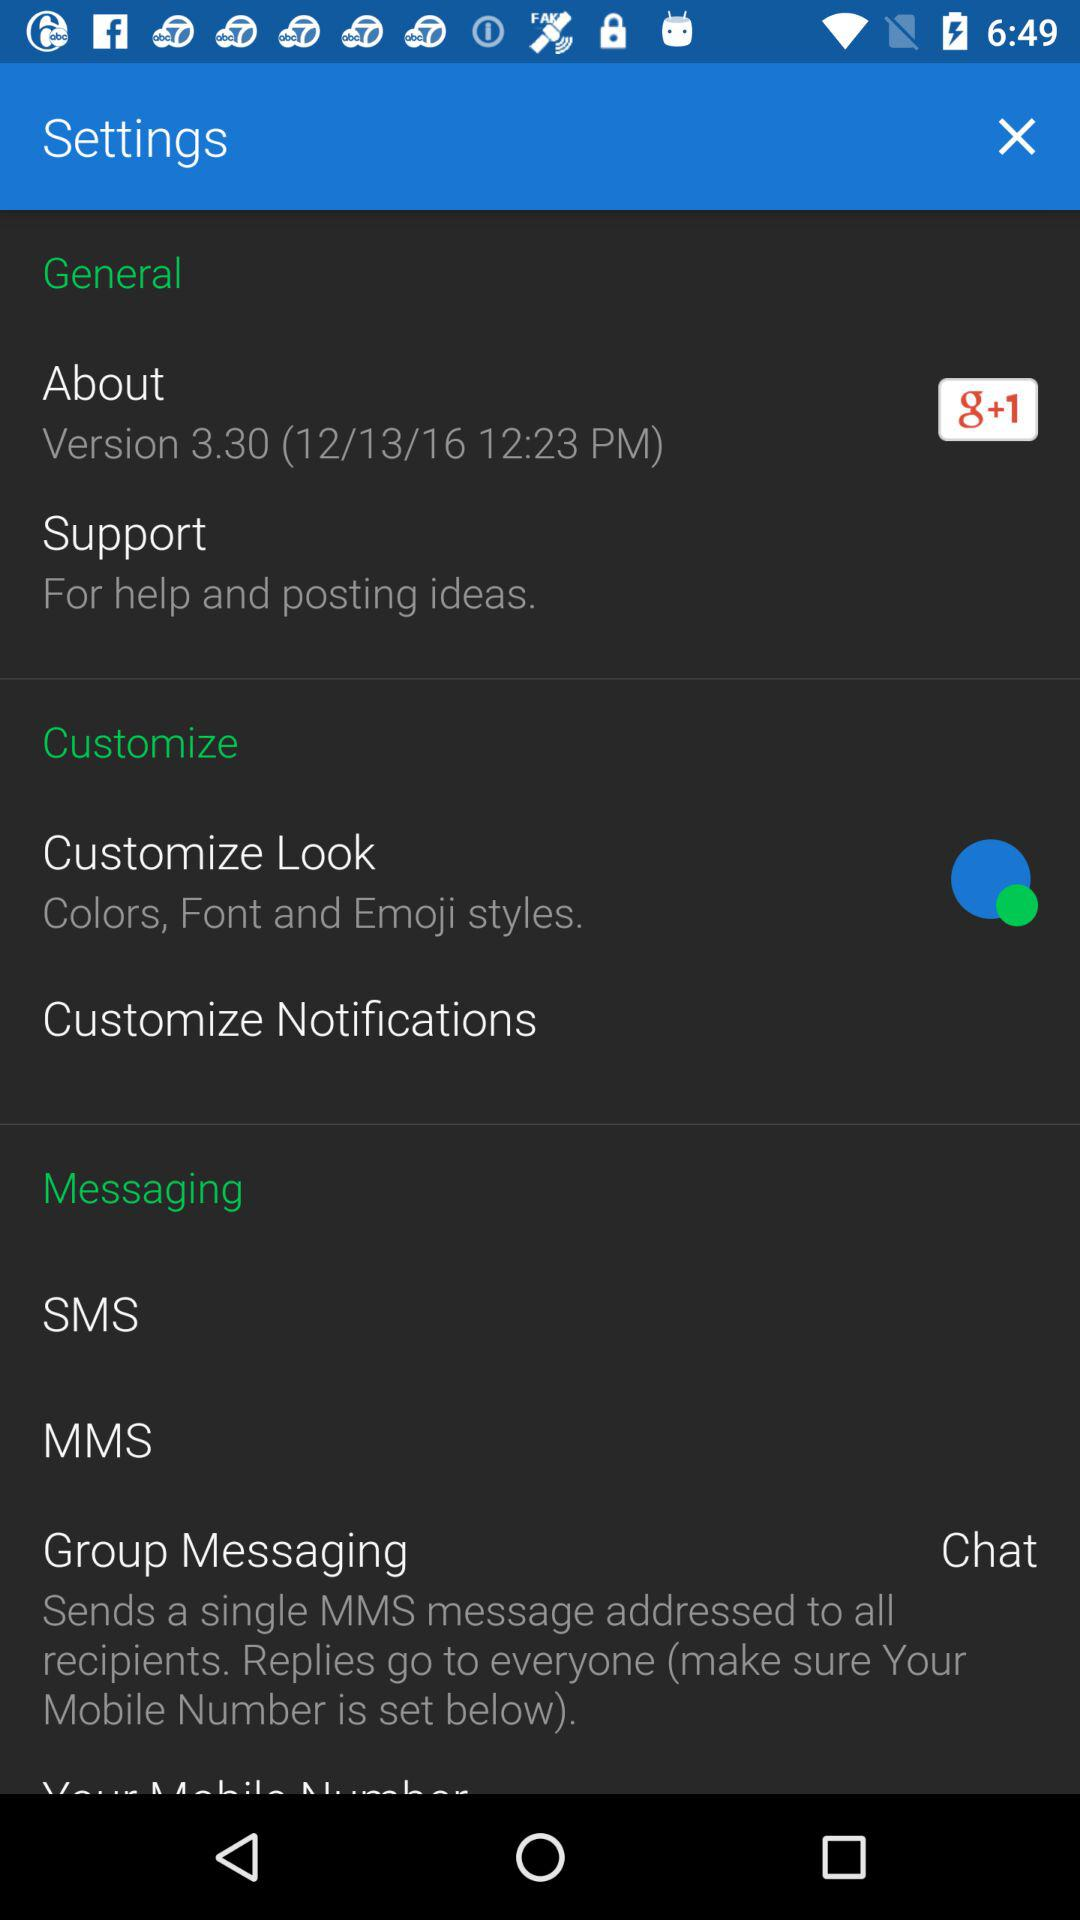At what time was version 3.30 released? Version 3.30 was released at 12:23 p.m. 